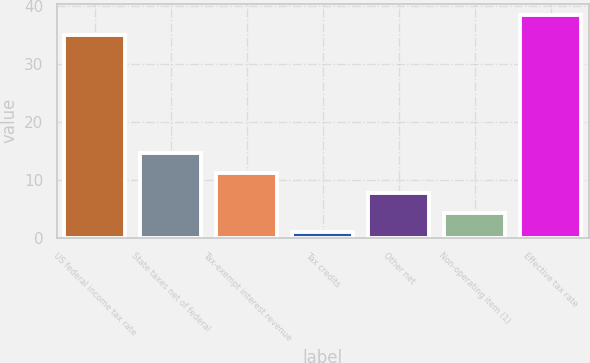Convert chart. <chart><loc_0><loc_0><loc_500><loc_500><bar_chart><fcel>US federal income tax rate<fcel>State taxes net of federal<fcel>Tax-exempt interest revenue<fcel>Tax credits<fcel>Other net<fcel>Non-operating item (1)<fcel>Effective tax rate<nl><fcel>35<fcel>14.58<fcel>11.16<fcel>0.9<fcel>7.74<fcel>4.32<fcel>38.42<nl></chart> 